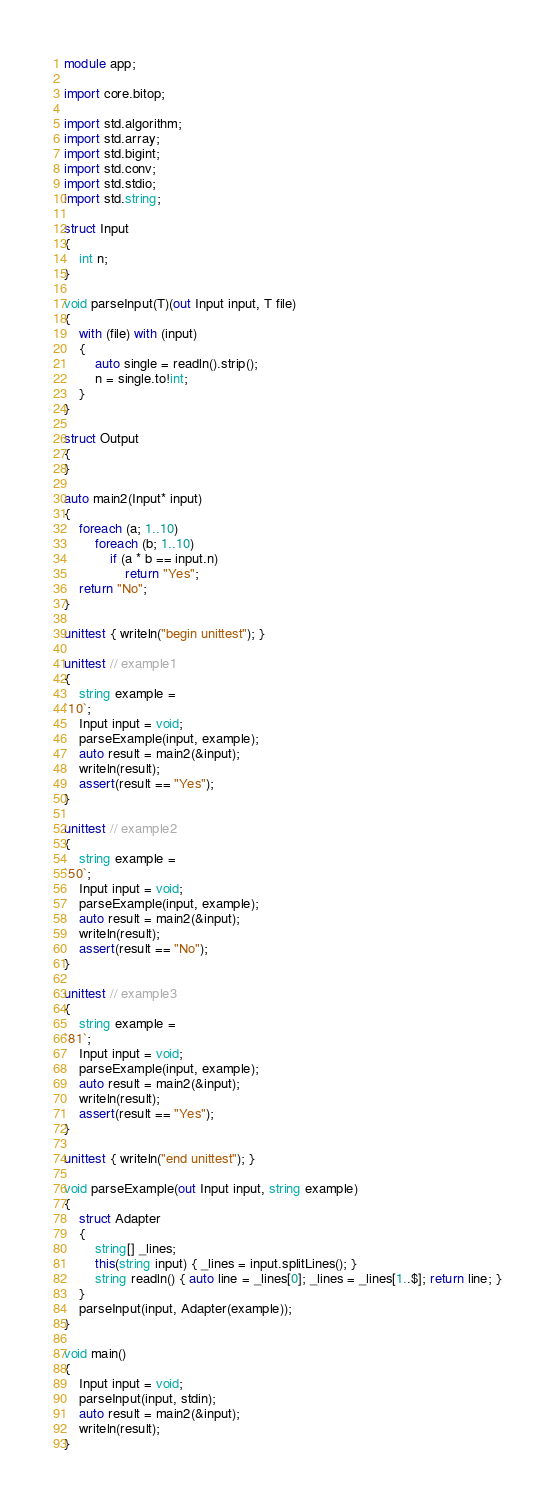Convert code to text. <code><loc_0><loc_0><loc_500><loc_500><_D_>module app;

import core.bitop;

import std.algorithm;
import std.array;
import std.bigint;
import std.conv;
import std.stdio;
import std.string;

struct Input
{
	int n;
}

void parseInput(T)(out Input input, T file)
{
	with (file) with (input)
	{
		auto single = readln().strip();
        n = single.to!int;
	}
}

struct Output
{
}

auto main2(Input* input)
{
    foreach (a; 1..10)
        foreach (b; 1..10)
            if (a * b == input.n)
                return "Yes";
    return "No";
}

unittest { writeln("begin unittest"); }

unittest // example1
{
	string example =
`10`;
	Input input = void;
	parseExample(input, example);
	auto result = main2(&input);
	writeln(result);
	assert(result == "Yes");
}

unittest // example2
{
	string example =
`50`;
	Input input = void;
	parseExample(input, example);
	auto result = main2(&input);
	writeln(result);
	assert(result == "No");
}

unittest // example3
{
	string example =
`81`;
	Input input = void;
	parseExample(input, example);
	auto result = main2(&input);
	writeln(result);
	assert(result == "Yes");
}

unittest { writeln("end unittest"); }

void parseExample(out Input input, string example)
{
	struct Adapter
	{
		string[] _lines;
		this(string input) { _lines = input.splitLines(); }
		string readln() { auto line = _lines[0]; _lines = _lines[1..$]; return line; }
	}
	parseInput(input, Adapter(example));
}

void main()
{
	Input input = void;
	parseInput(input, stdin);
	auto result = main2(&input);
	writeln(result);
}
</code> 